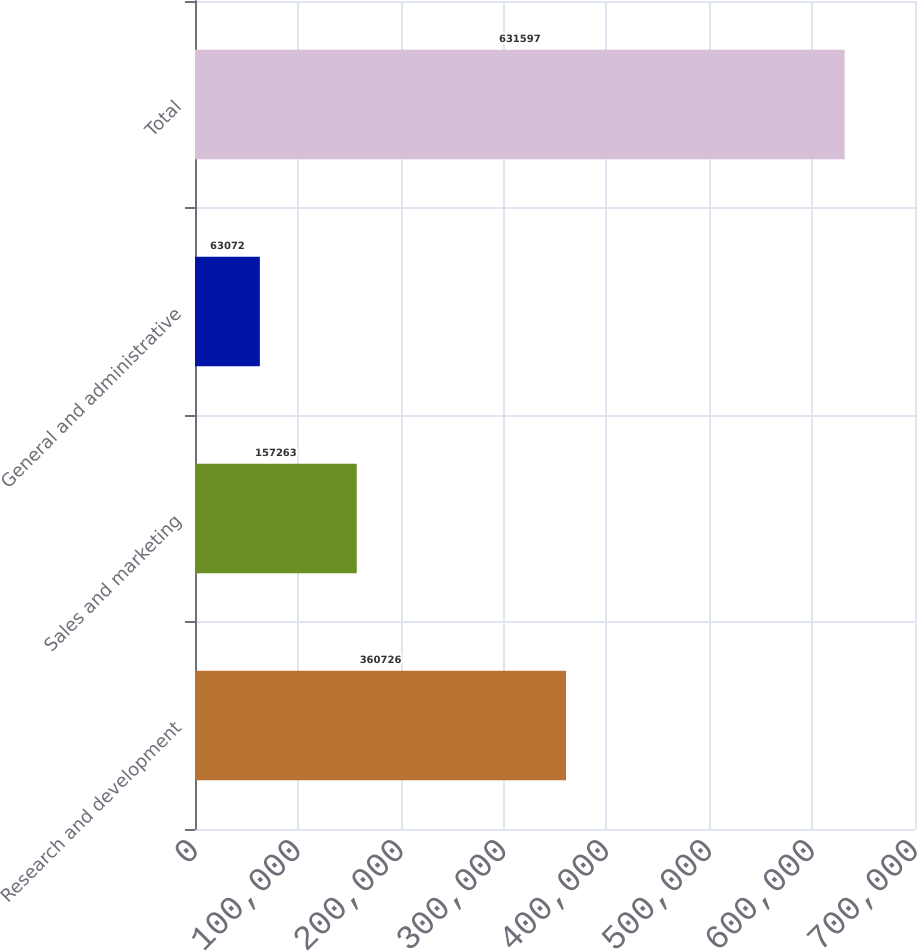<chart> <loc_0><loc_0><loc_500><loc_500><bar_chart><fcel>Research and development<fcel>Sales and marketing<fcel>General and administrative<fcel>Total<nl><fcel>360726<fcel>157263<fcel>63072<fcel>631597<nl></chart> 